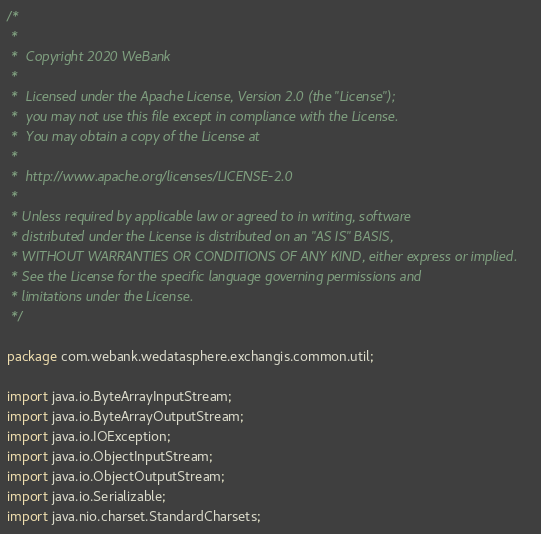Convert code to text. <code><loc_0><loc_0><loc_500><loc_500><_Java_>/*
 *
 *  Copyright 2020 WeBank
 *
 *  Licensed under the Apache License, Version 2.0 (the "License");
 *  you may not use this file except in compliance with the License.
 *  You may obtain a copy of the License at
 *
 *  http://www.apache.org/licenses/LICENSE-2.0
 *
 * Unless required by applicable law or agreed to in writing, software
 * distributed under the License is distributed on an "AS IS" BASIS,
 * WITHOUT WARRANTIES OR CONDITIONS OF ANY KIND, either express or implied.
 * See the License for the specific language governing permissions and
 * limitations under the License.
 */

package com.webank.wedatasphere.exchangis.common.util;

import java.io.ByteArrayInputStream;
import java.io.ByteArrayOutputStream;
import java.io.IOException;
import java.io.ObjectInputStream;
import java.io.ObjectOutputStream;
import java.io.Serializable;
import java.nio.charset.StandardCharsets;</code> 